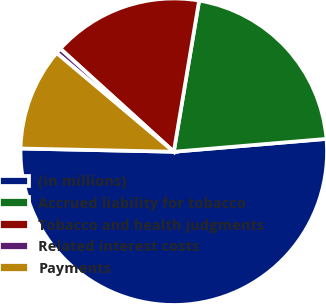<chart> <loc_0><loc_0><loc_500><loc_500><pie_chart><fcel>(in millions)<fcel>Accrued liability for tobacco<fcel>Tobacco and health judgments<fcel>Related interest costs<fcel>Payments<nl><fcel>51.67%<fcel>21.02%<fcel>15.91%<fcel>0.59%<fcel>10.81%<nl></chart> 